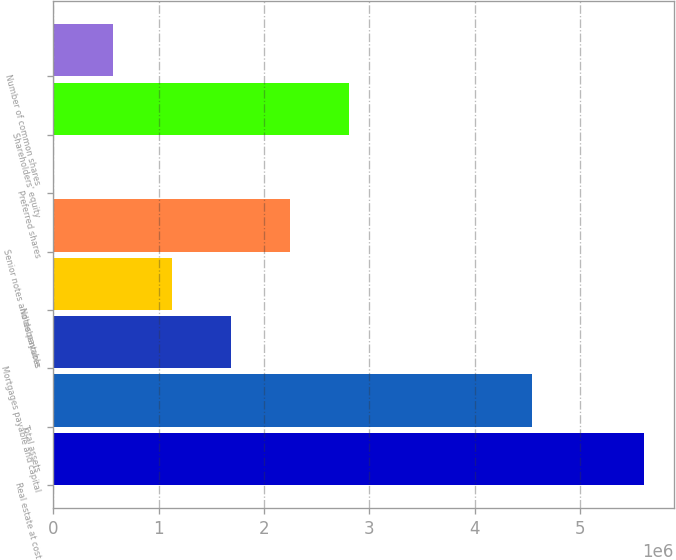<chart> <loc_0><loc_0><loc_500><loc_500><bar_chart><fcel>Real estate at cost<fcel>Total assets<fcel>Mortgages payable and capital<fcel>Notes payable<fcel>Senior notes and debentures<fcel>Preferred shares<fcel>Shareholders' equity<fcel>Number of common shares<nl><fcel>5.609e+06<fcel>4.54687e+06<fcel>1.6897e+06<fcel>1.1298e+06<fcel>2.2496e+06<fcel>9997<fcel>2.8095e+06<fcel>569897<nl></chart> 